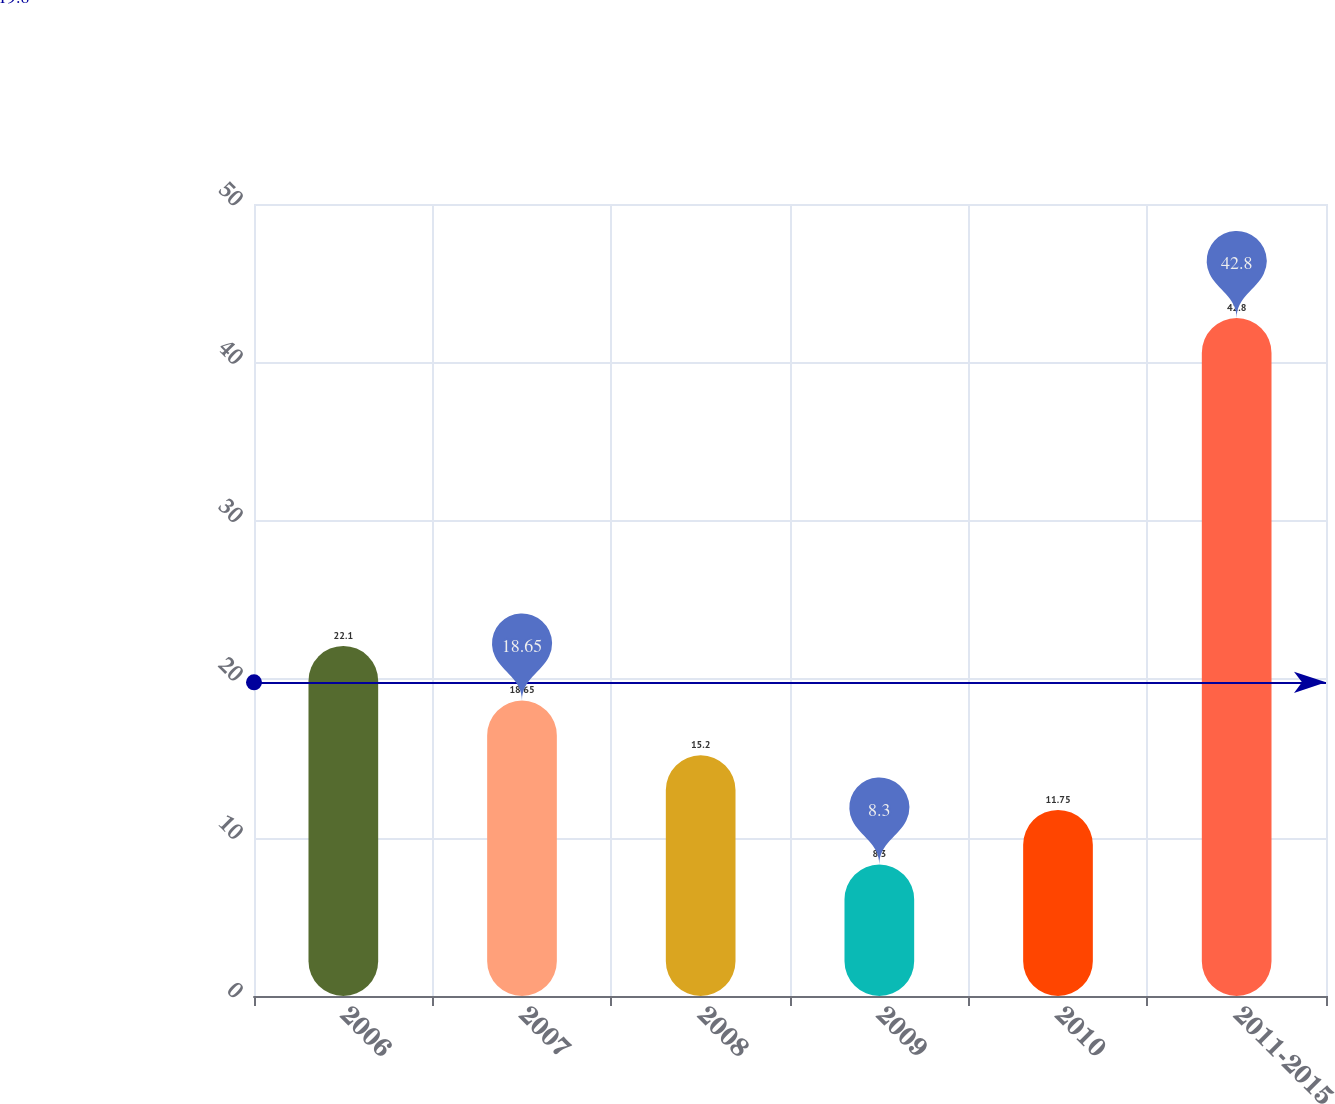Convert chart to OTSL. <chart><loc_0><loc_0><loc_500><loc_500><bar_chart><fcel>2006<fcel>2007<fcel>2008<fcel>2009<fcel>2010<fcel>2011-2015<nl><fcel>22.1<fcel>18.65<fcel>15.2<fcel>8.3<fcel>11.75<fcel>42.8<nl></chart> 